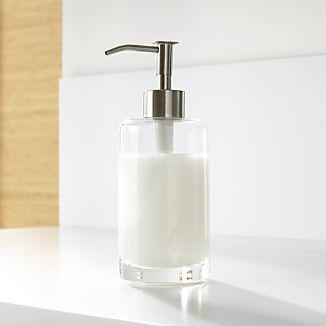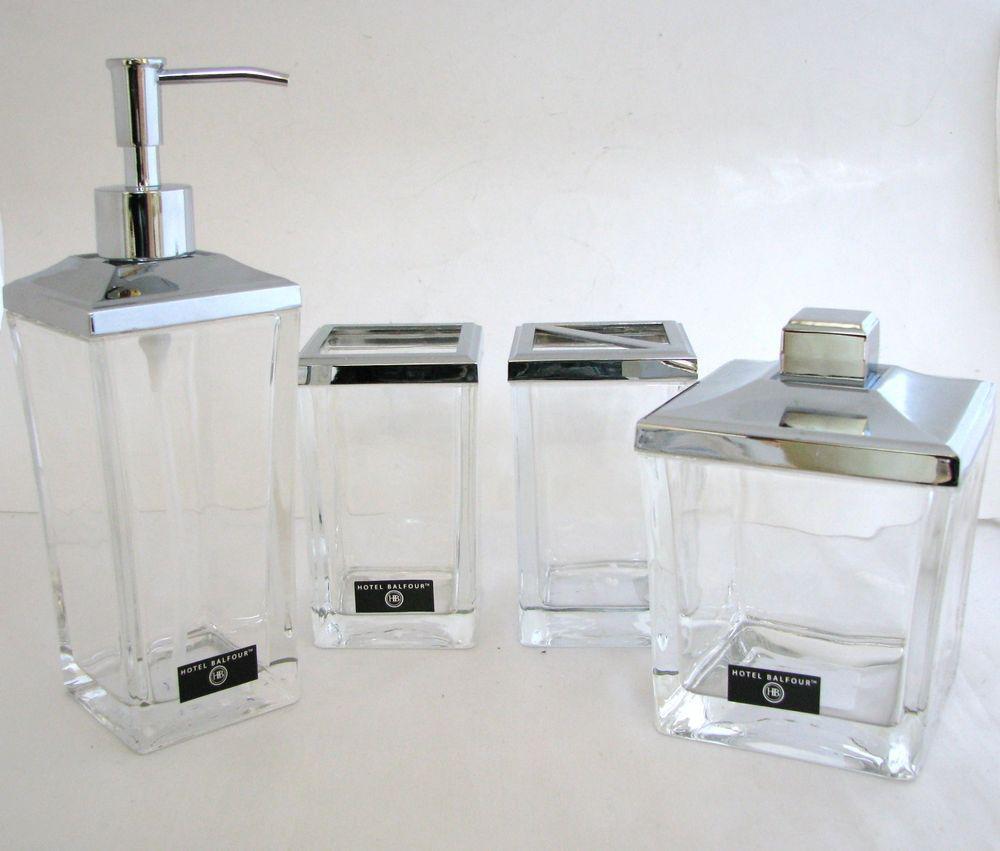The first image is the image on the left, the second image is the image on the right. For the images displayed, is the sentence "The left and right image contains the same number of soap dispenser that sit on the sink." factually correct? Answer yes or no. Yes. The first image is the image on the left, the second image is the image on the right. For the images displayed, is the sentence "There is a clear dispenser with white lotion in it." factually correct? Answer yes or no. Yes. 